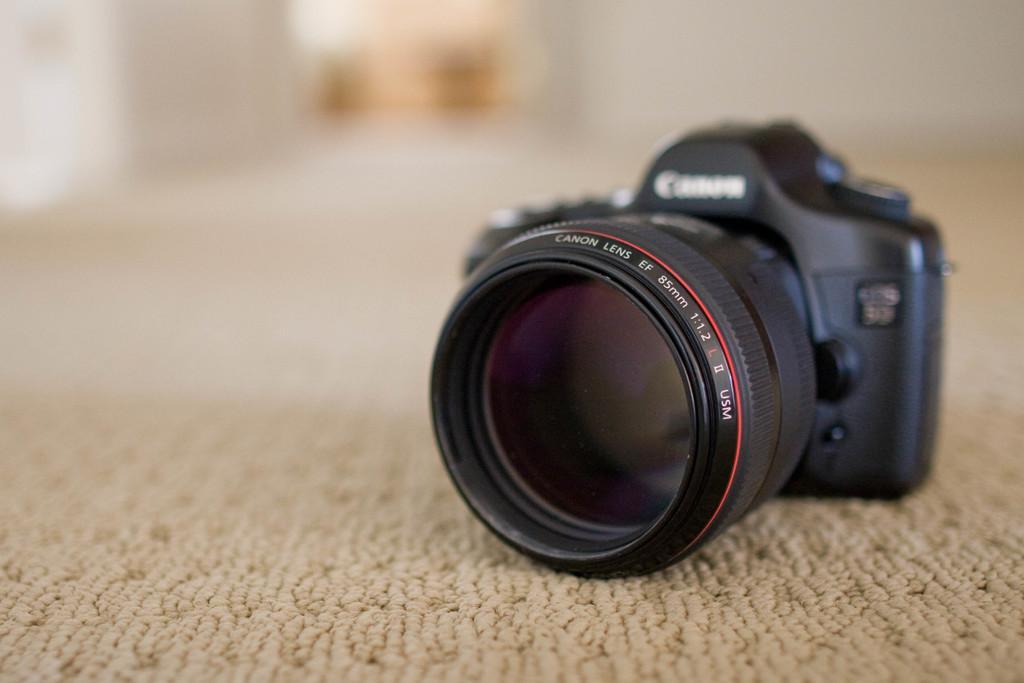Please provide a concise description of this image. In front of the image there is a camera on the mat and the background of the image is blur. 